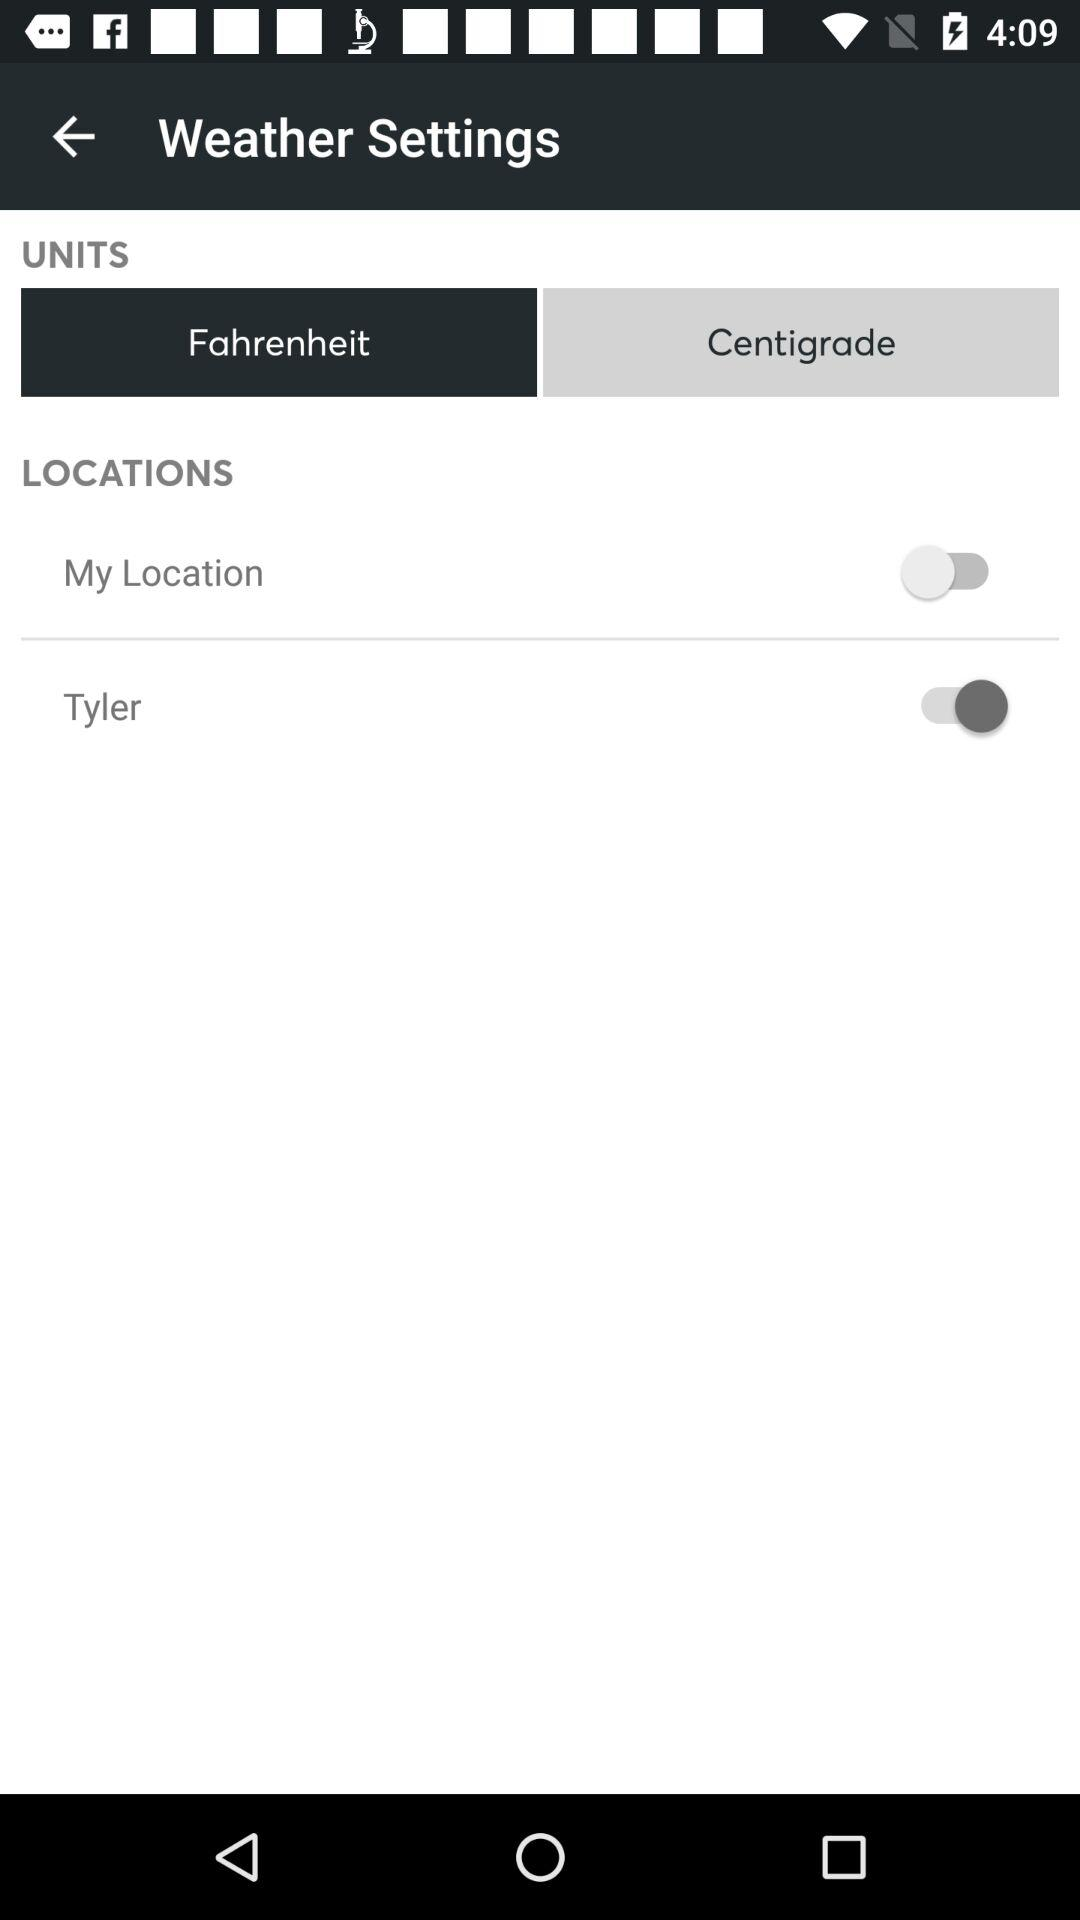For what option is the status off? The status is off for "My Location". 